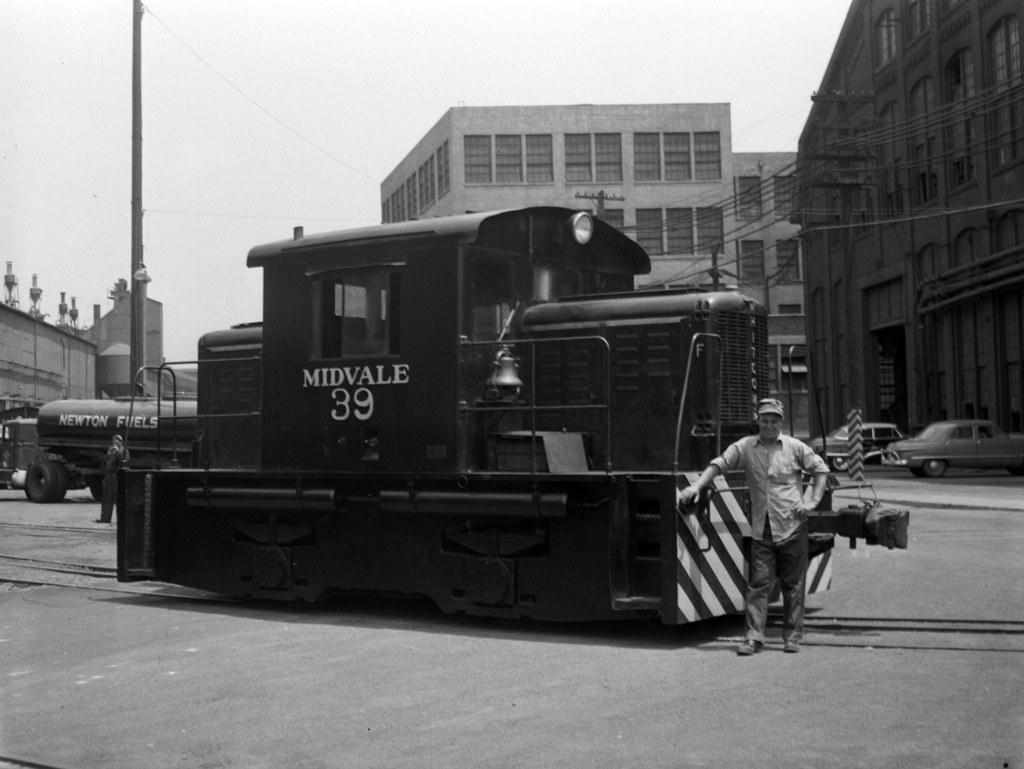What is the person in the image standing beside? The person is standing beside a train in the image. What can be seen in the background of the image? There are buildings and cars in the background of the image. Can you see any milk or liquid in the image? No, there is no milk or liquid visible in the image. 